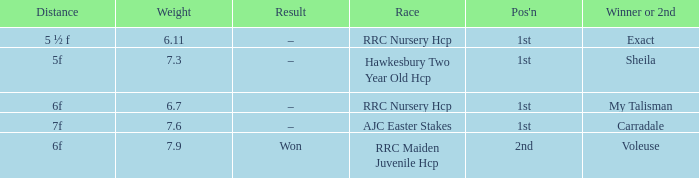What is the weight number when the distance was 5 ½ f? 1.0. 